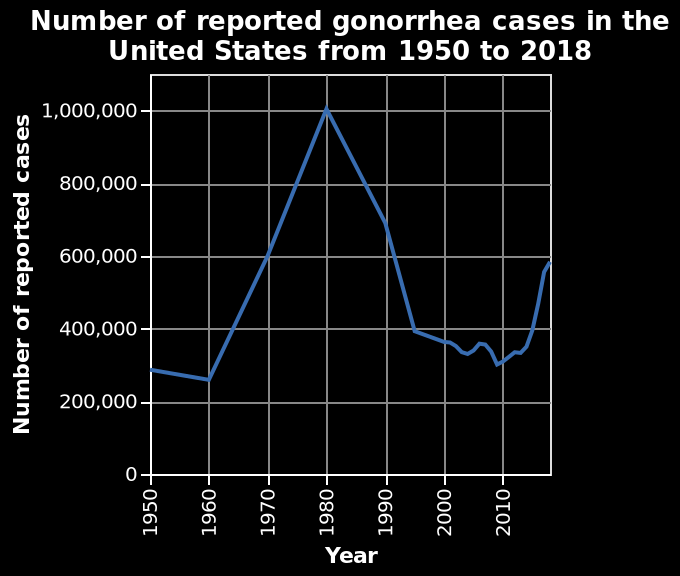<image>
Is the number of reported gonorrhea cases increasing or decreasing over time? The diagram does not provide information on whether the number of reported cases is increasing or decreasing. Offer a thorough analysis of the image. There is a small decrease in the number of cases of gonorrhoea between 1950-1960. Between 1960-1980 there is a surge in cases, reaching its peak of 1,000,000 in 1980. Between 1980-1990 there is a steady reduction in the number of cases. Around 1995 this has dropped rapidly to just below 400,000. There are small fluctuations until around 2015 where it begins to increase again. 